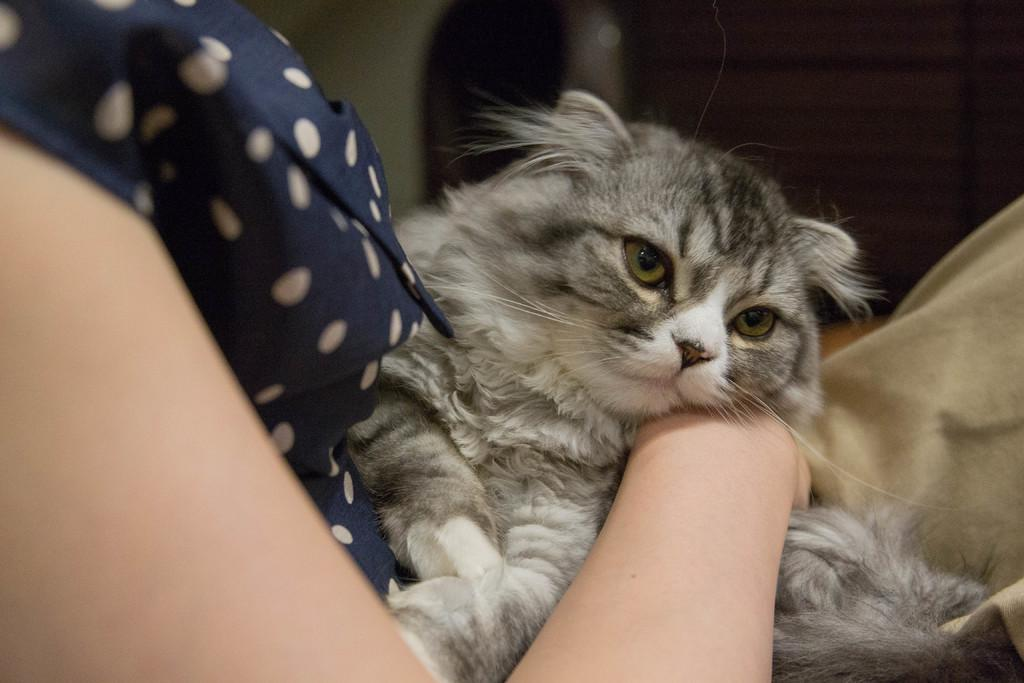What is the main subject of the image? There is a person in the image. What is the person holding in the image? The person is holding a cat. Can you describe the background of the image? The background of the image appears blurry. What flavor of alarm can be heard in the image? There is no alarm present in the image, and therefore no flavor can be determined. 